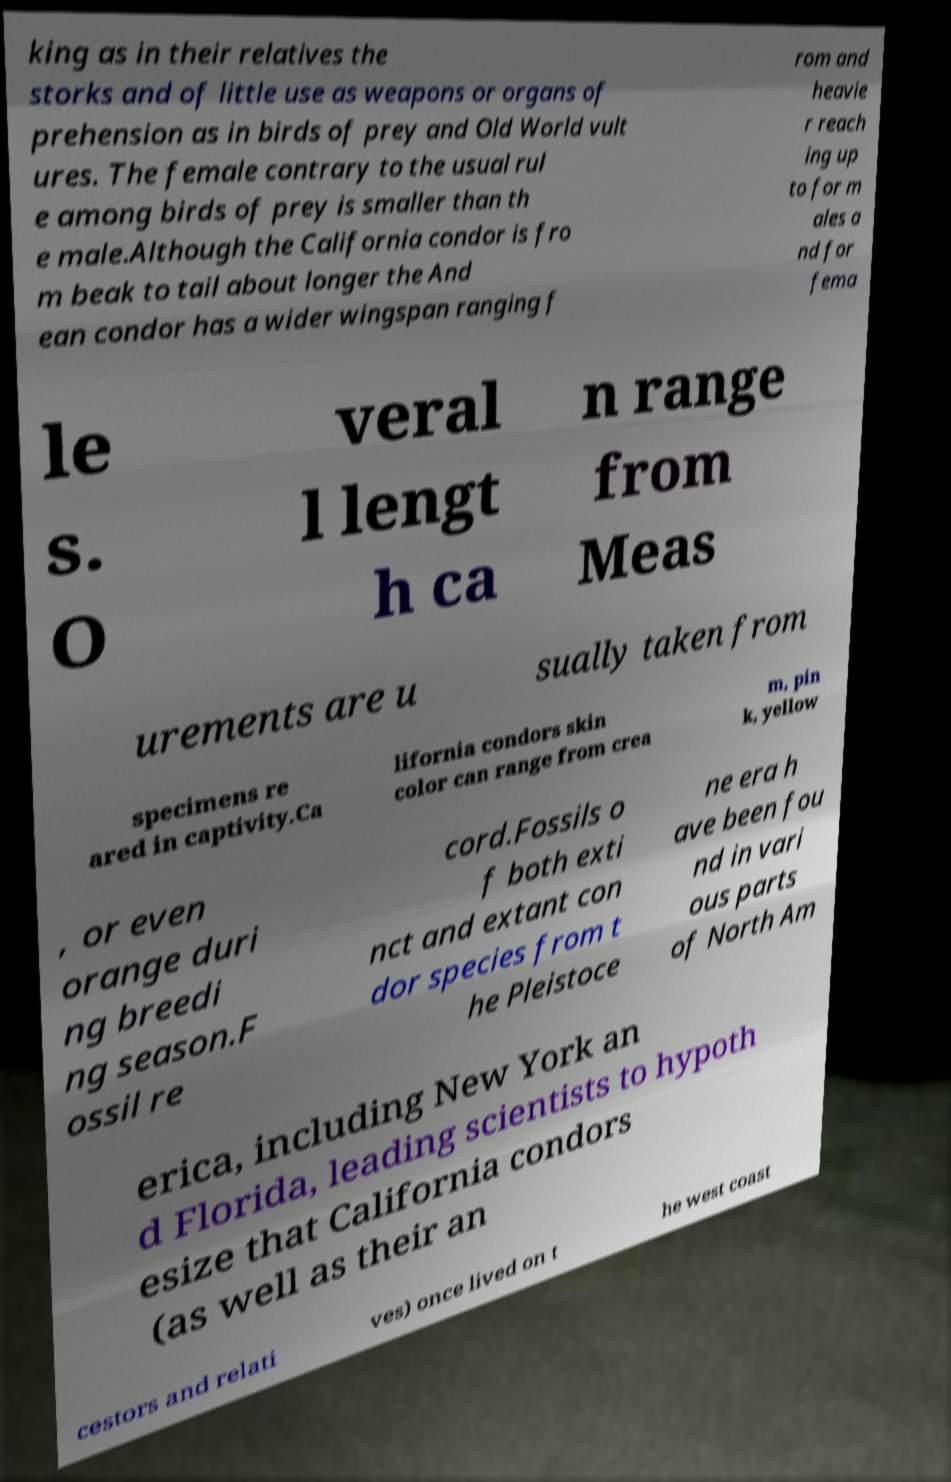Please identify and transcribe the text found in this image. king as in their relatives the storks and of little use as weapons or organs of prehension as in birds of prey and Old World vult ures. The female contrary to the usual rul e among birds of prey is smaller than th e male.Although the California condor is fro m beak to tail about longer the And ean condor has a wider wingspan ranging f rom and heavie r reach ing up to for m ales a nd for fema le s. O veral l lengt h ca n range from Meas urements are u sually taken from specimens re ared in captivity.Ca lifornia condors skin color can range from crea m, pin k, yellow , or even orange duri ng breedi ng season.F ossil re cord.Fossils o f both exti nct and extant con dor species from t he Pleistoce ne era h ave been fou nd in vari ous parts of North Am erica, including New York an d Florida, leading scientists to hypoth esize that California condors (as well as their an cestors and relati ves) once lived on t he west coast 